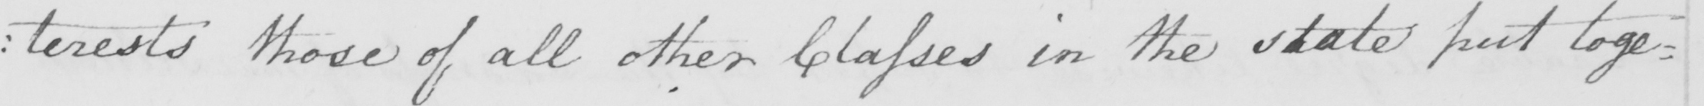Transcribe the text shown in this historical manuscript line. : terests those of all other Classes in the state put toge= 